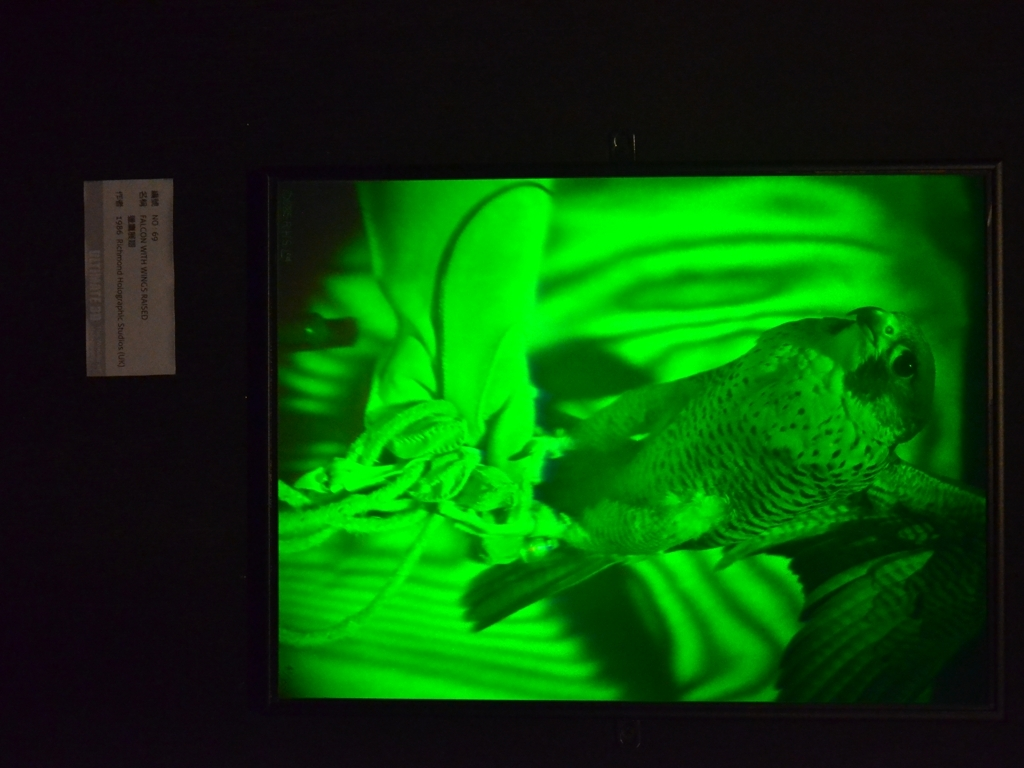Are there any visible artifacts in the image? No visible artifacts are present in the image. The image displays a framed picture with a vibrant greenish hue, showcasing what appears to be a bird in mid-motion, captured with clear and sharp detail, without any distortions or imperfections that would suggest the presence of artifacts. 